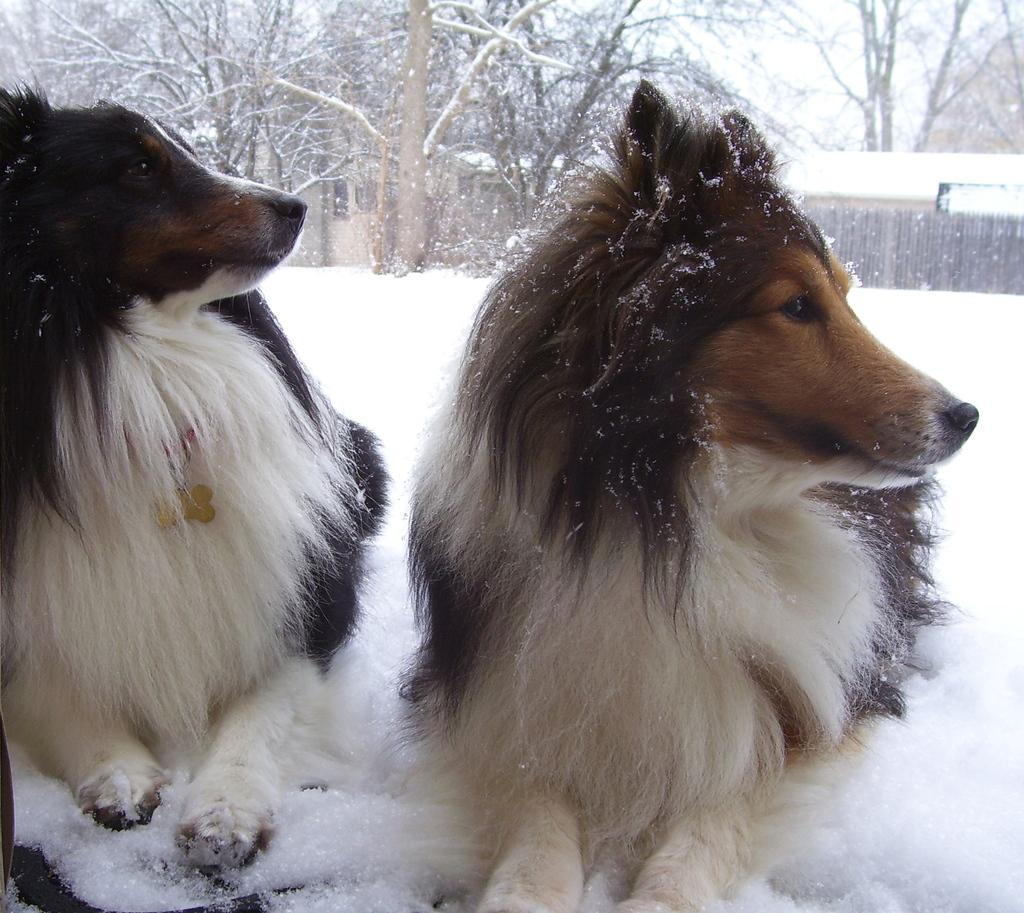How many dogs are in the image? There are two dogs in the image. What is the surface the dogs are standing on? The dogs are on the snow. What can be seen in the background of the image? There are trees and a house in the background of the image. What type of fencing is present in the image? There is a wooden fencing in the image. What type of salt is being used to season the dogs in the image? There is no salt present in the image, nor is there any indication that the dogs are being seasoned. 